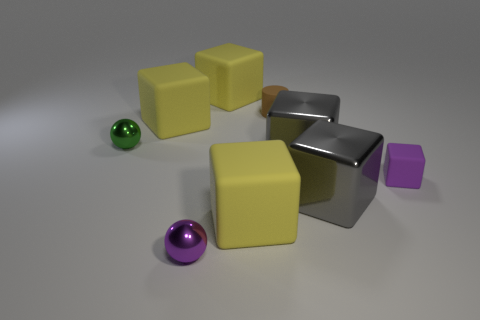Subtract all purple spheres. How many yellow blocks are left? 3 Subtract all gray cubes. How many cubes are left? 4 Subtract all matte cubes. How many cubes are left? 2 Subtract 3 blocks. How many blocks are left? 3 Subtract all cyan blocks. Subtract all yellow cylinders. How many blocks are left? 6 Subtract all cubes. How many objects are left? 3 Add 6 small shiny spheres. How many small shiny spheres are left? 8 Add 2 big matte things. How many big matte things exist? 5 Subtract 2 yellow cubes. How many objects are left? 7 Subtract all gray metallic objects. Subtract all tiny green metallic objects. How many objects are left? 6 